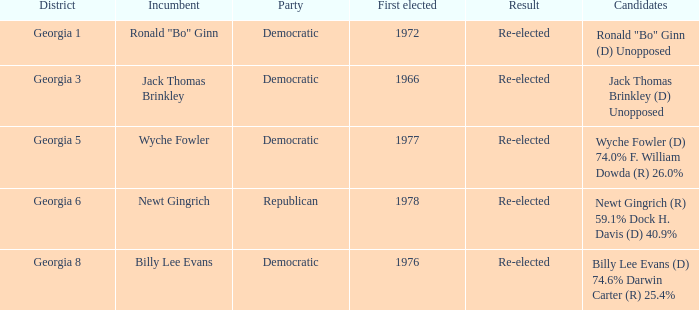What is the earliest first elected for district georgia 1? 1972.0. 